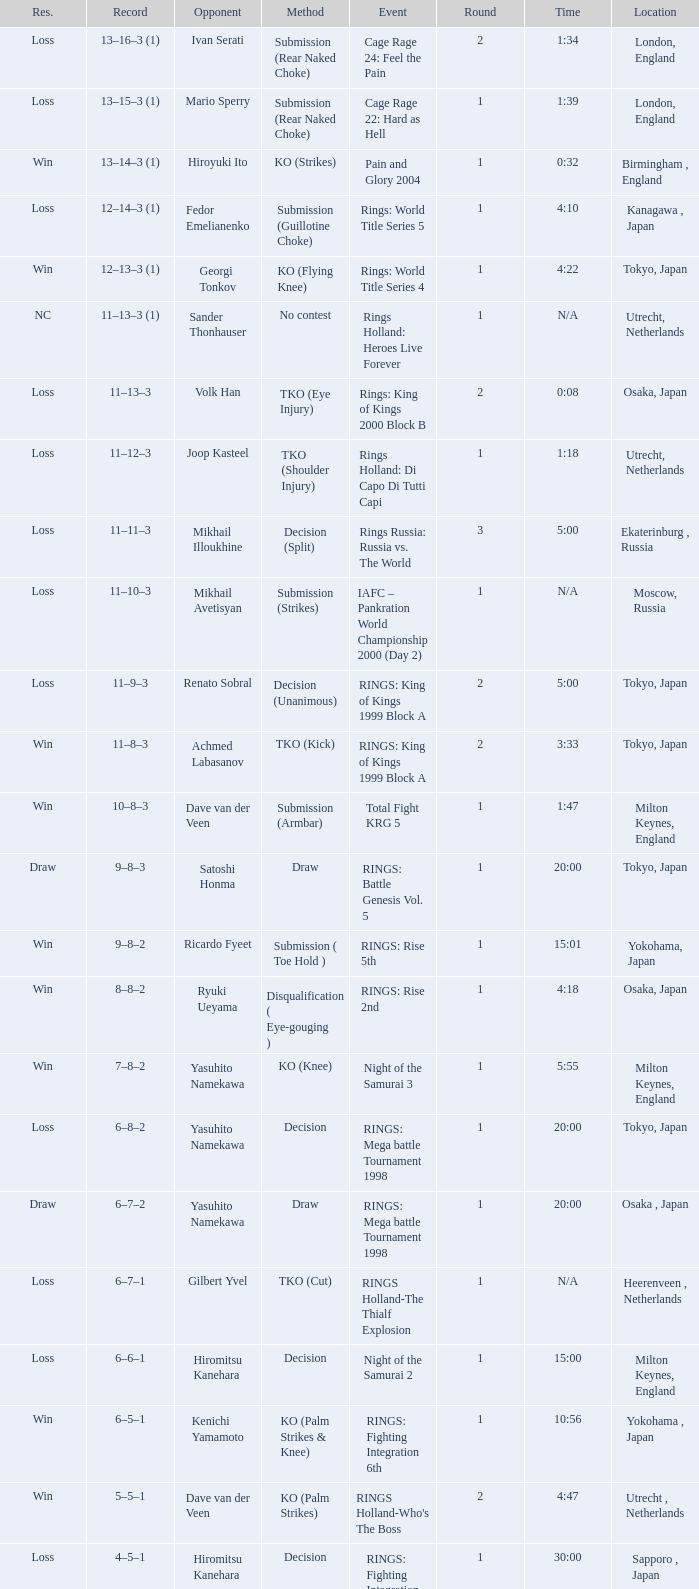What is the current time in moscow, russia? N/A. 